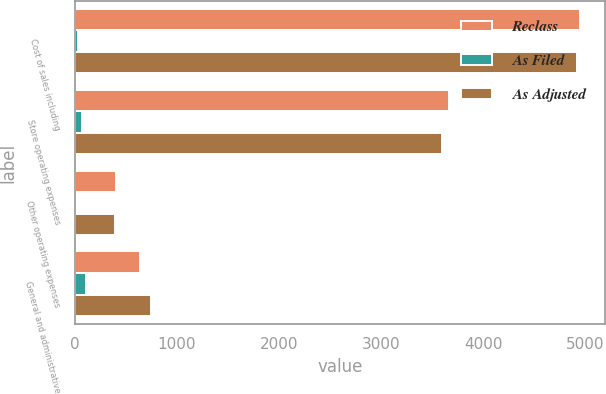Convert chart. <chart><loc_0><loc_0><loc_500><loc_500><stacked_bar_chart><ecel><fcel>Cost of sales including<fcel>Store operating expenses<fcel>Other operating expenses<fcel>General and administrative<nl><fcel>Reclass<fcel>4949.3<fcel>3665.1<fcel>402<fcel>636.1<nl><fcel>As Filed<fcel>33.8<fcel>70.2<fcel>9.2<fcel>113.2<nl><fcel>As Adjusted<fcel>4915.5<fcel>3594.9<fcel>392.8<fcel>749.3<nl></chart> 